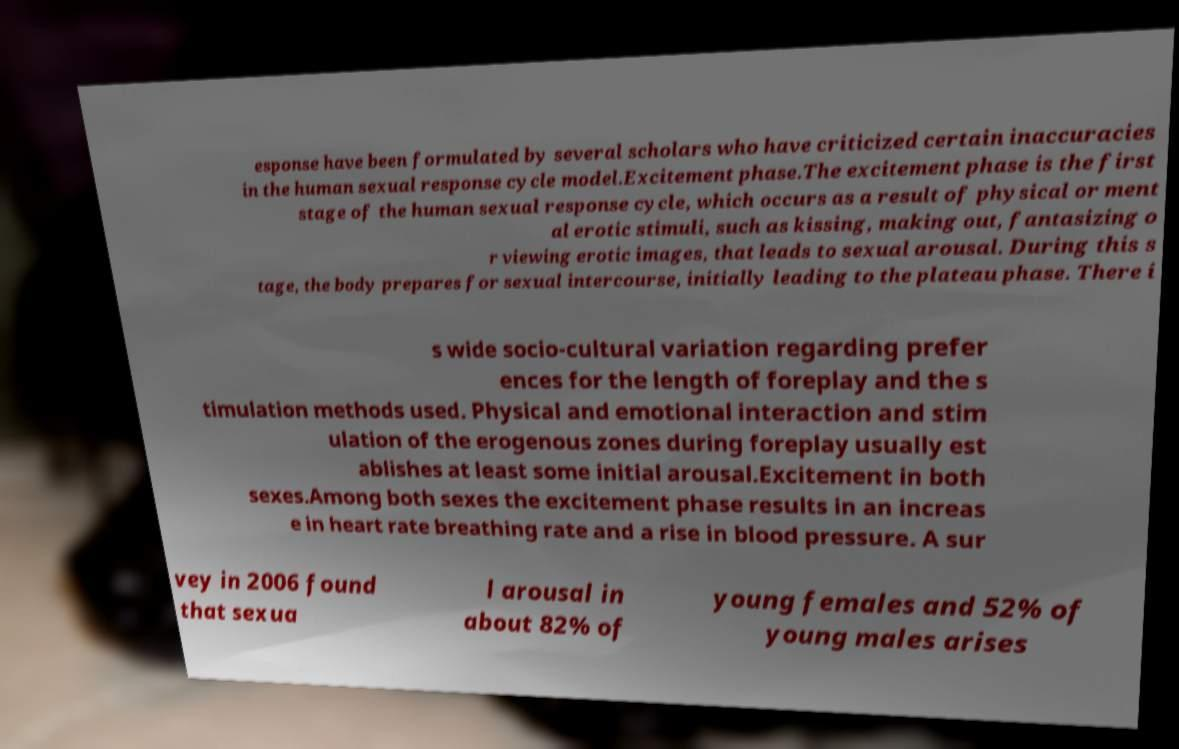Please read and relay the text visible in this image. What does it say? esponse have been formulated by several scholars who have criticized certain inaccuracies in the human sexual response cycle model.Excitement phase.The excitement phase is the first stage of the human sexual response cycle, which occurs as a result of physical or ment al erotic stimuli, such as kissing, making out, fantasizing o r viewing erotic images, that leads to sexual arousal. During this s tage, the body prepares for sexual intercourse, initially leading to the plateau phase. There i s wide socio-cultural variation regarding prefer ences for the length of foreplay and the s timulation methods used. Physical and emotional interaction and stim ulation of the erogenous zones during foreplay usually est ablishes at least some initial arousal.Excitement in both sexes.Among both sexes the excitement phase results in an increas e in heart rate breathing rate and a rise in blood pressure. A sur vey in 2006 found that sexua l arousal in about 82% of young females and 52% of young males arises 